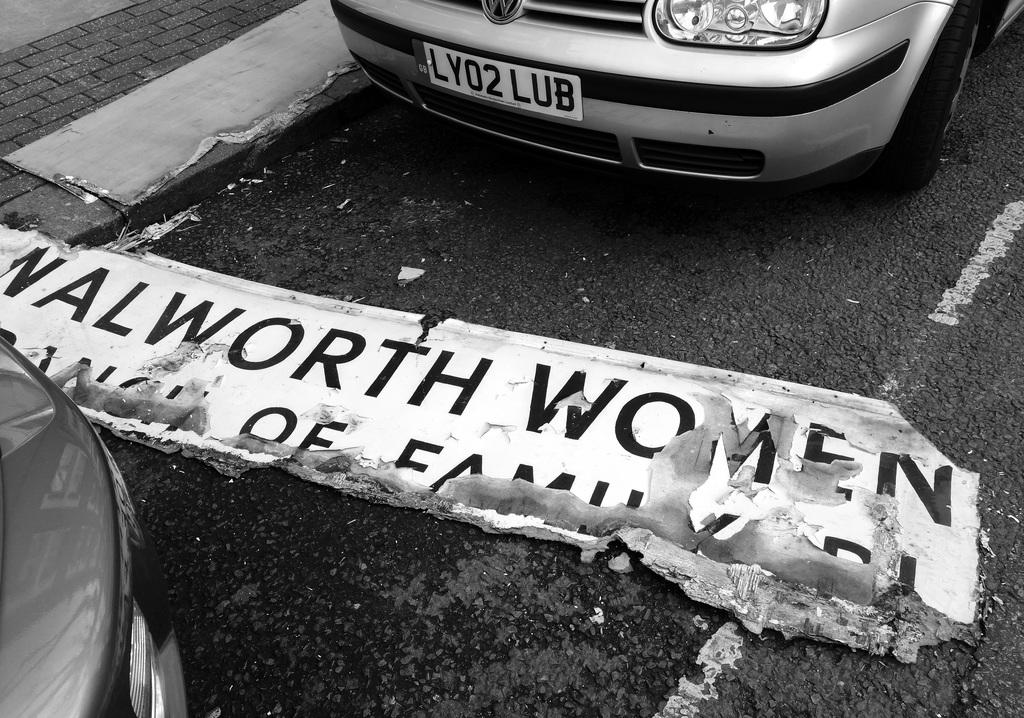<image>
Write a terse but informative summary of the picture. A sign that says "Walworth Women" is on the ground and is damaged. 